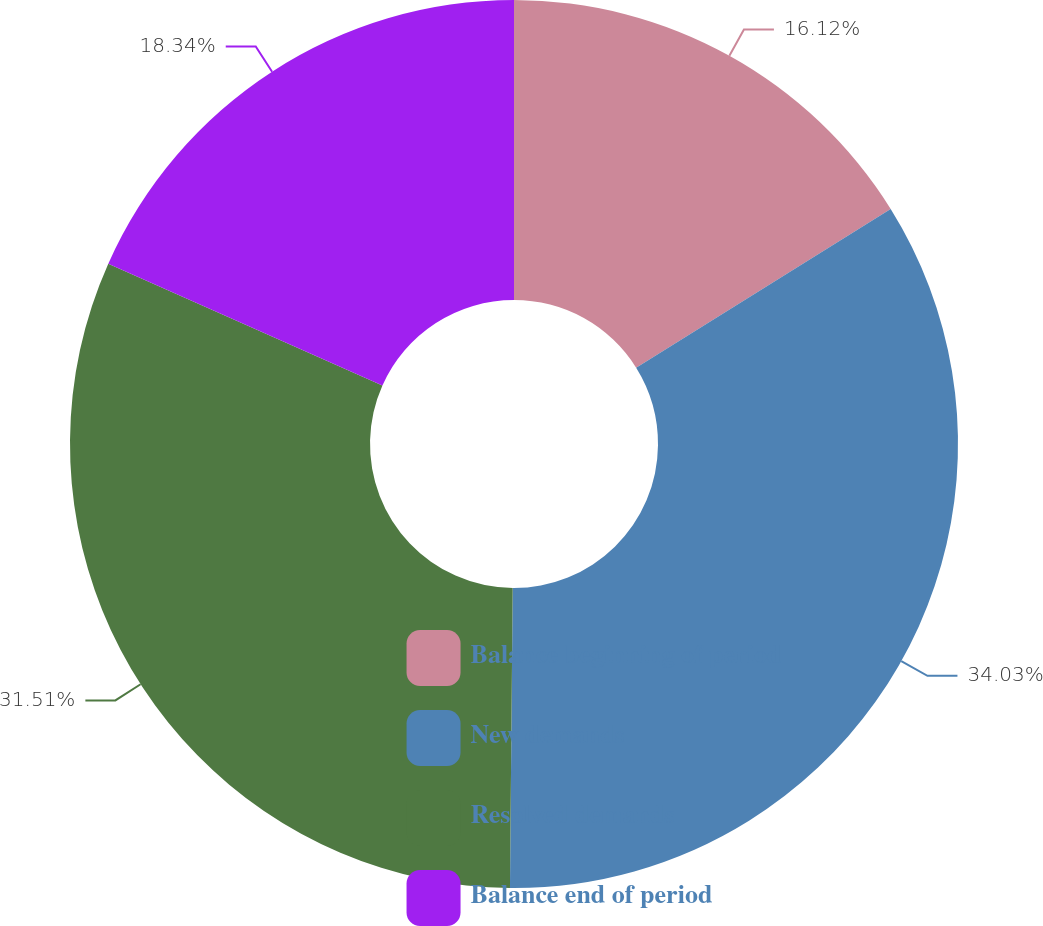Convert chart to OTSL. <chart><loc_0><loc_0><loc_500><loc_500><pie_chart><fcel>Balance beginning of period<fcel>New demands<fcel>Resolved demands<fcel>Balance end of period<nl><fcel>16.12%<fcel>34.02%<fcel>31.51%<fcel>18.34%<nl></chart> 